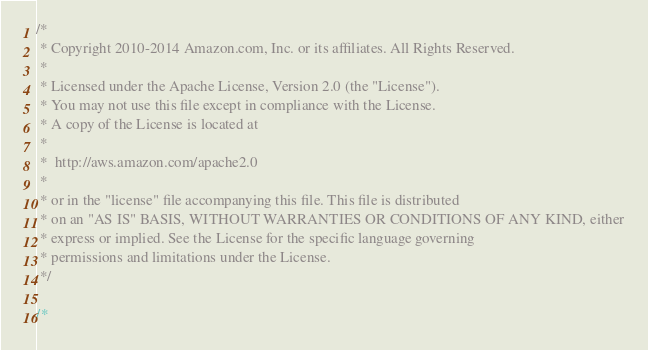Convert code to text. <code><loc_0><loc_0><loc_500><loc_500><_C#_>/*
 * Copyright 2010-2014 Amazon.com, Inc. or its affiliates. All Rights Reserved.
 * 
 * Licensed under the Apache License, Version 2.0 (the "License").
 * You may not use this file except in compliance with the License.
 * A copy of the License is located at
 * 
 *  http://aws.amazon.com/apache2.0
 * 
 * or in the "license" file accompanying this file. This file is distributed
 * on an "AS IS" BASIS, WITHOUT WARRANTIES OR CONDITIONS OF ANY KIND, either
 * express or implied. See the License for the specific language governing
 * permissions and limitations under the License.
 */

/*</code> 